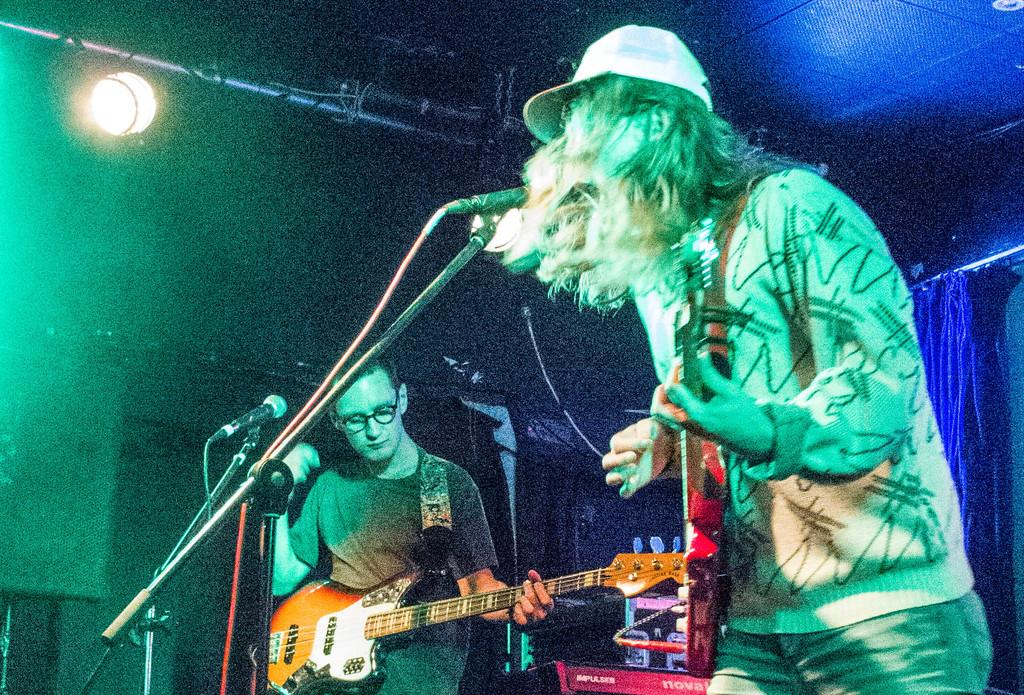How many people are in the image? There are two men in the image. What are the men doing in the image? The men are standing and playing musical instruments. What can be seen in the image that might be used for lighting? There is a stage light in the image. What can be seen in the image that might be used for amplifying sound? There are microphones in the image. What other objects can be seen in the image? There are other objects present in the image, but their specific details are not mentioned in the provided facts. What is the income of the men in the image? The provided facts do not mention any information about the men's income, so it cannot be determined from the image. 